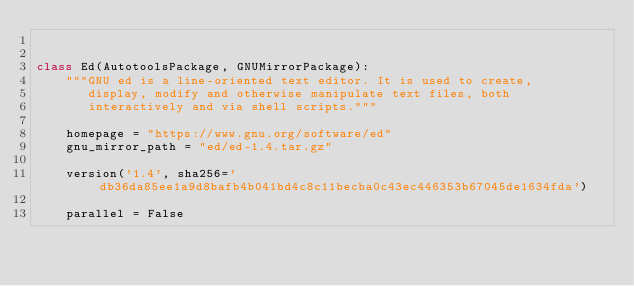Convert code to text. <code><loc_0><loc_0><loc_500><loc_500><_Python_>

class Ed(AutotoolsPackage, GNUMirrorPackage):
    """GNU ed is a line-oriented text editor. It is used to create,
       display, modify and otherwise manipulate text files, both
       interactively and via shell scripts."""

    homepage = "https://www.gnu.org/software/ed"
    gnu_mirror_path = "ed/ed-1.4.tar.gz"

    version('1.4', sha256='db36da85ee1a9d8bafb4b041bd4c8c11becba0c43ec446353b67045de1634fda')

    parallel = False
</code> 